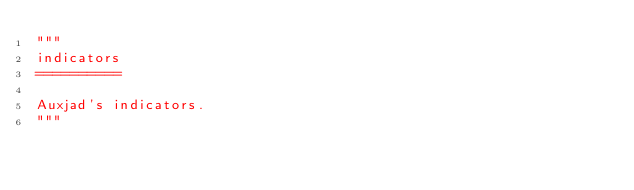Convert code to text. <code><loc_0><loc_0><loc_500><loc_500><_Python_>"""
indicators
==========

Auxjad's indicators.
"""
</code> 